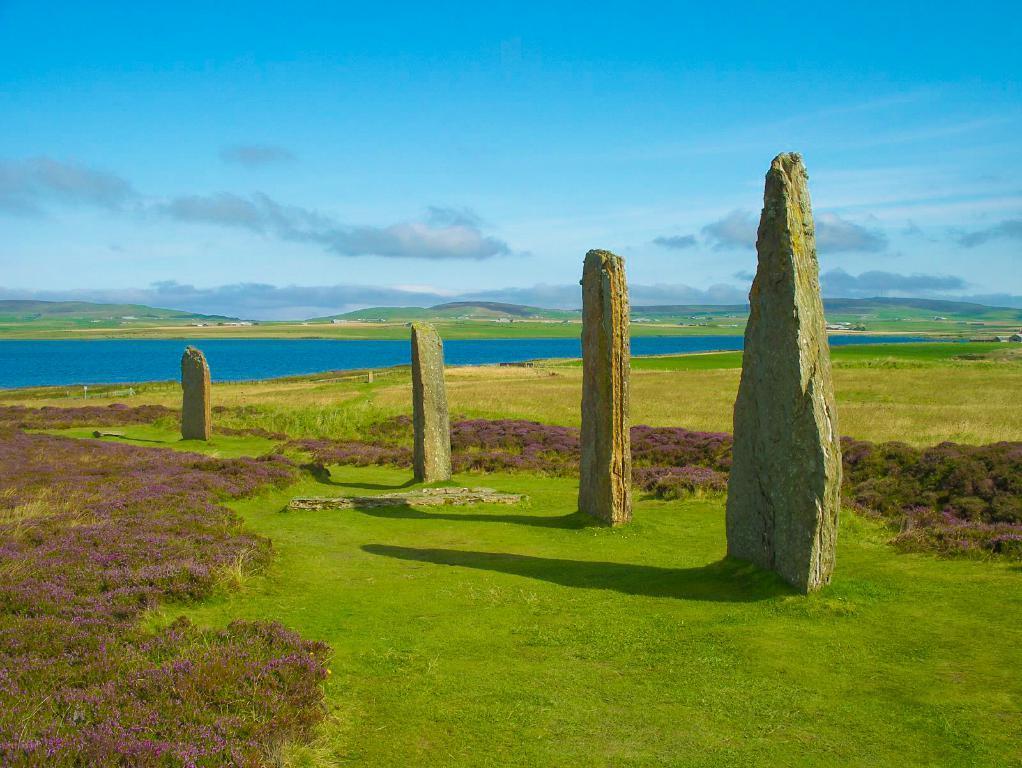In one or two sentences, can you explain what this image depicts? As we can see in the image there are rocks, grass and water. On the top there is sky and clouds. 